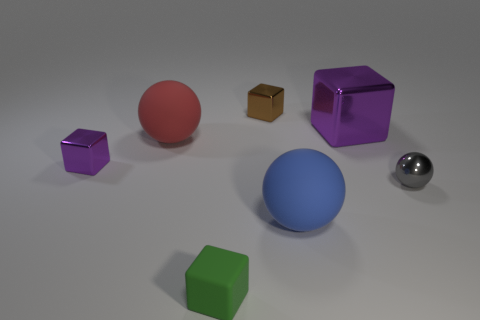Subtract all cyan balls. Subtract all brown cylinders. How many balls are left? 3 Add 1 tiny rubber blocks. How many objects exist? 8 Subtract all spheres. How many objects are left? 4 Add 4 gray shiny objects. How many gray shiny objects are left? 5 Add 5 big blue matte balls. How many big blue matte balls exist? 6 Subtract 0 brown spheres. How many objects are left? 7 Subtract all big blue cubes. Subtract all large rubber spheres. How many objects are left? 5 